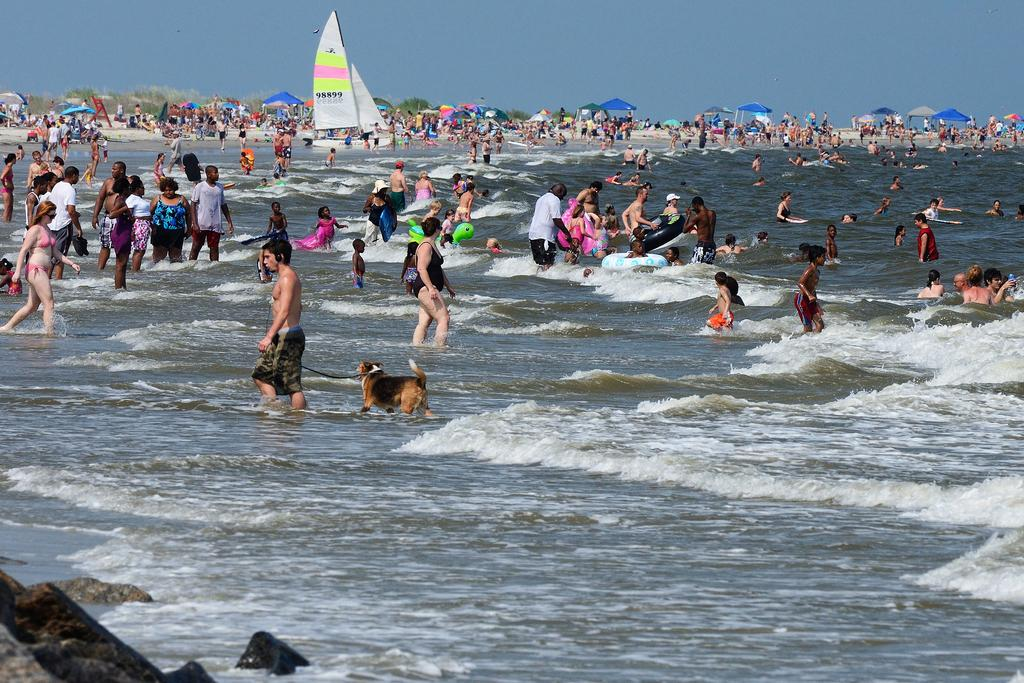What type of vehicles are on the water in the image? There are boats on the water in the image. What animal is present in the image? There is a dog in the image. What are the people in the image doing? There is a group of people standing in the water. What objects are in the water that can be used for swimming? There are inflatable swim rings in the water. What unique feature can be seen on the pipes in the image? There are pipes with umbrellas in the image. What type of vegetation is visible in the image? Trees are visible in the image. What part of the natural environment is visible in the image? The sky is visible in the image. What type of tree is being taught to read in the image? There is no tree present in the image, nor is there any indication of teaching or reading. What event is taking place in the image? There is no specific event depicted in the image; it shows boats, a dog, people, swim rings, pipes with umbrellas, trees, and the sky. 